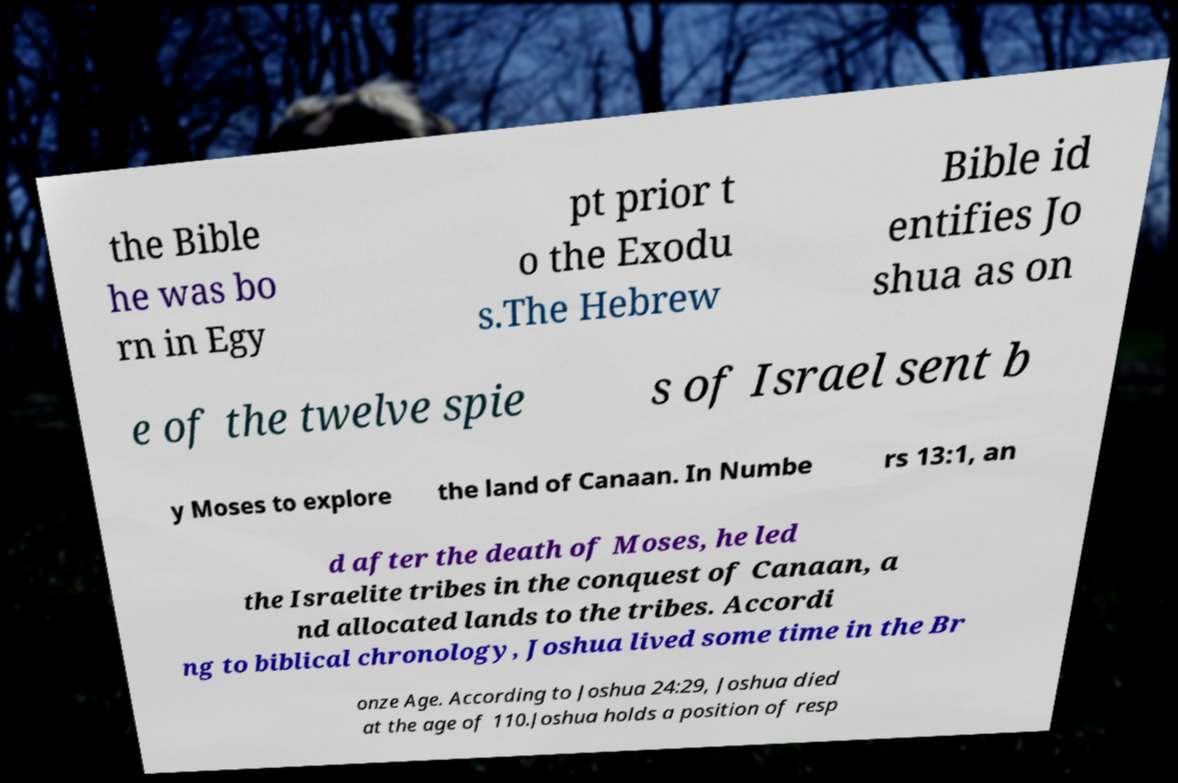Can you accurately transcribe the text from the provided image for me? the Bible he was bo rn in Egy pt prior t o the Exodu s.The Hebrew Bible id entifies Jo shua as on e of the twelve spie s of Israel sent b y Moses to explore the land of Canaan. In Numbe rs 13:1, an d after the death of Moses, he led the Israelite tribes in the conquest of Canaan, a nd allocated lands to the tribes. Accordi ng to biblical chronology, Joshua lived some time in the Br onze Age. According to Joshua 24:29, Joshua died at the age of 110.Joshua holds a position of resp 